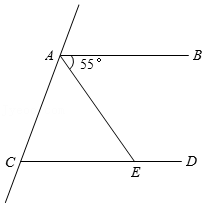How might the angles contribute to proving lines AB and CD are parallel? To prove that lines AB and CD are parallel using the given angles, one could use the Converse of the Corresponding Angles Postulate. If the angle formed at point A (55°) is equal to the corresponding angle formed at point E when extended, it confirms that lines AB and CD are parallel because corresponding angles are equal when a transversal intersects parallel lines. Could there be any other geometric principles applicable here? Yes, besides the corresponding angles postulate, the Alternate Interior Angles Theorem could also be applicable, assuming the diagram is extended to clarify angle positions. This theorem could help further verify the parallel nature of lines AB and CD through additional equal angles created by the transversal. 